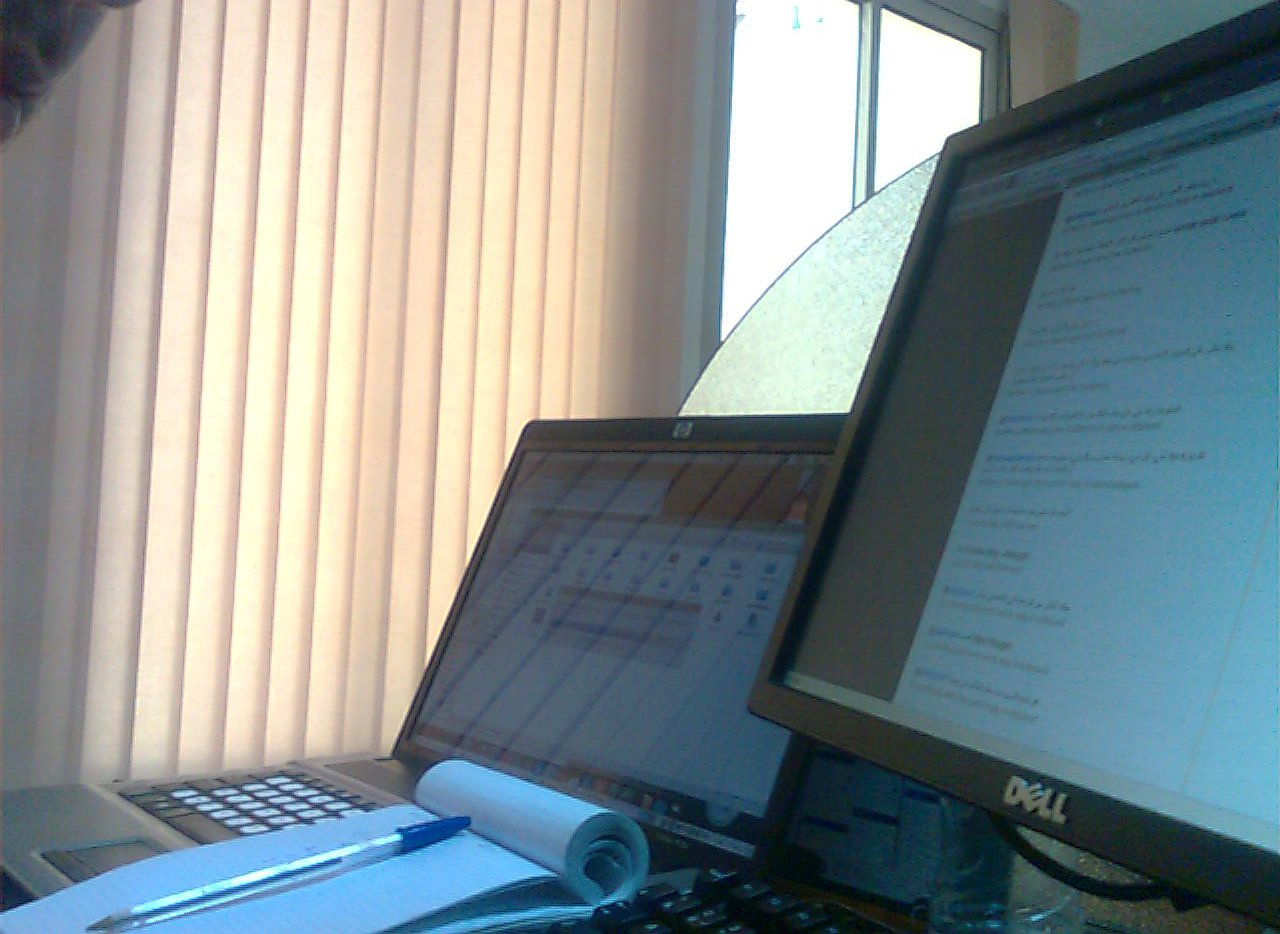Which color is the cap, blue or maroon? The cap is blue, specifically a deep navy, which contrasts with the lighter blue pen nearby. 